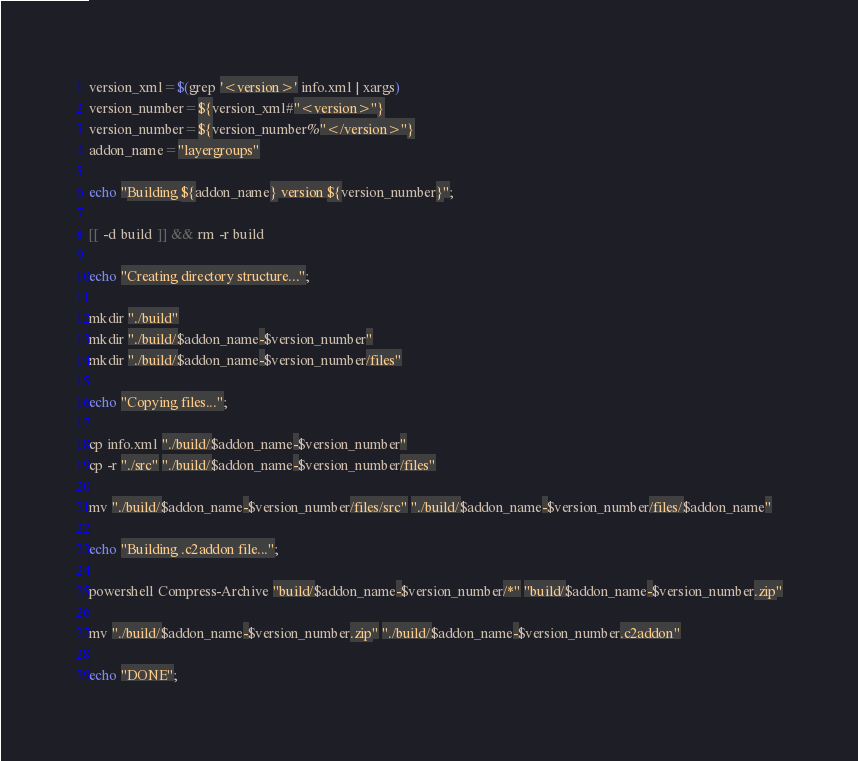<code> <loc_0><loc_0><loc_500><loc_500><_Bash_>version_xml=$(grep '<version>' info.xml | xargs)
version_number=${version_xml#"<version>"}
version_number=${version_number%"</version>"}
addon_name="layergroups"

echo "Building ${addon_name} version ${version_number}";

[[ -d build ]] && rm -r build

echo "Creating directory structure...";

mkdir "./build"
mkdir "./build/$addon_name-$version_number"
mkdir "./build/$addon_name-$version_number/files"

echo "Copying files...";

cp info.xml "./build/$addon_name-$version_number"
cp -r "./src" "./build/$addon_name-$version_number/files"

mv "./build/$addon_name-$version_number/files/src" "./build/$addon_name-$version_number/files/$addon_name"

echo "Building .c2addon file...";

powershell Compress-Archive "build/$addon_name-$version_number/*" "build/$addon_name-$version_number.zip"

mv "./build/$addon_name-$version_number.zip" "./build/$addon_name-$version_number.c2addon" 

echo "DONE";</code> 